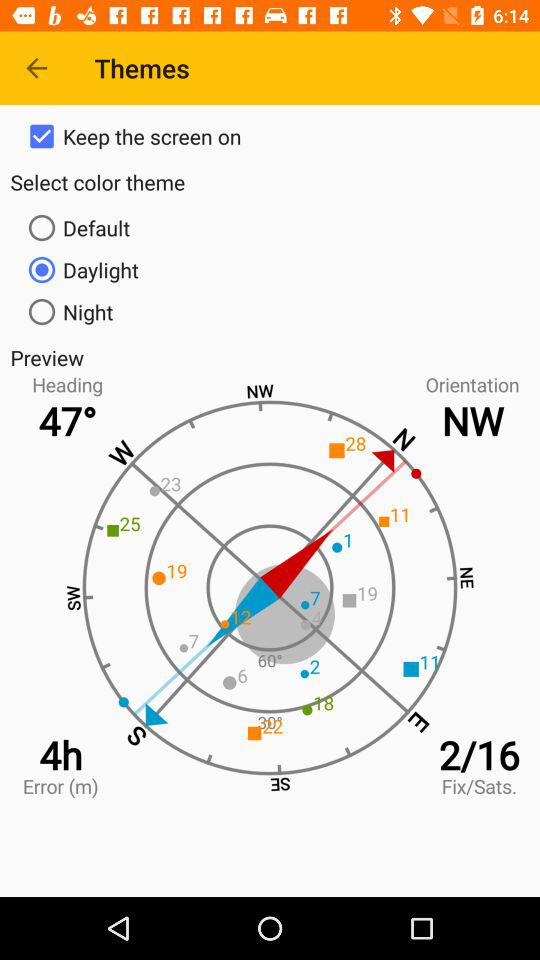How many theme options are there?
Answer the question using a single word or phrase. 3 